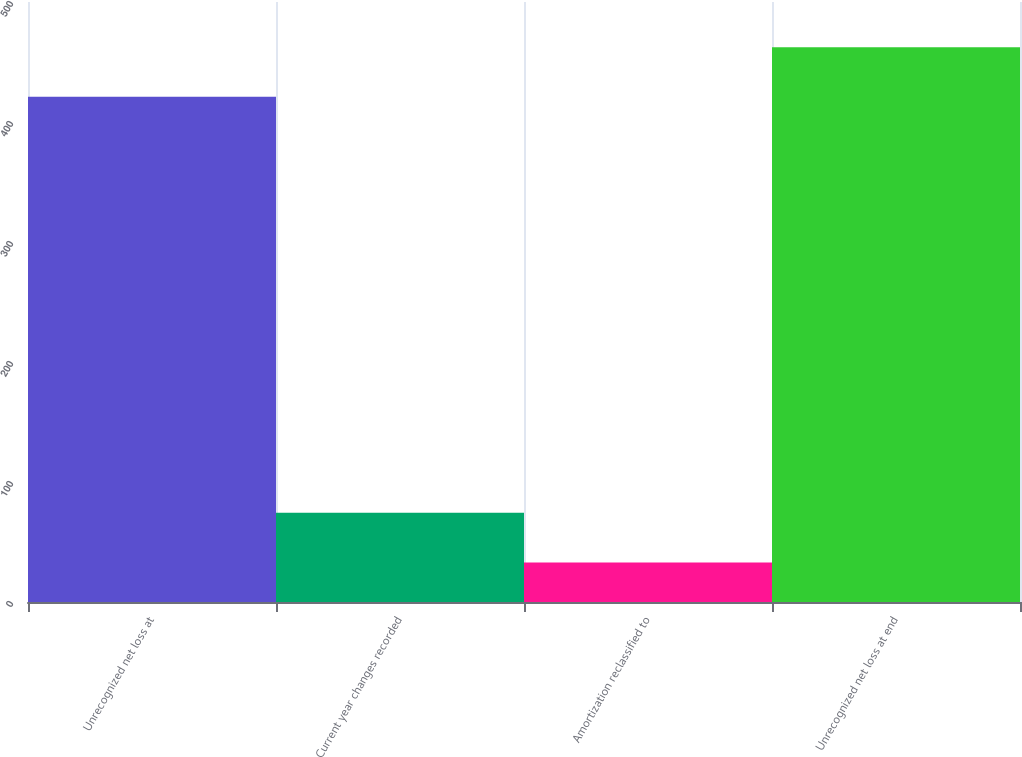Convert chart. <chart><loc_0><loc_0><loc_500><loc_500><bar_chart><fcel>Unrecognized net loss at<fcel>Current year changes recorded<fcel>Amortization reclassified to<fcel>Unrecognized net loss at end<nl><fcel>421<fcel>74.3<fcel>33<fcel>462.3<nl></chart> 